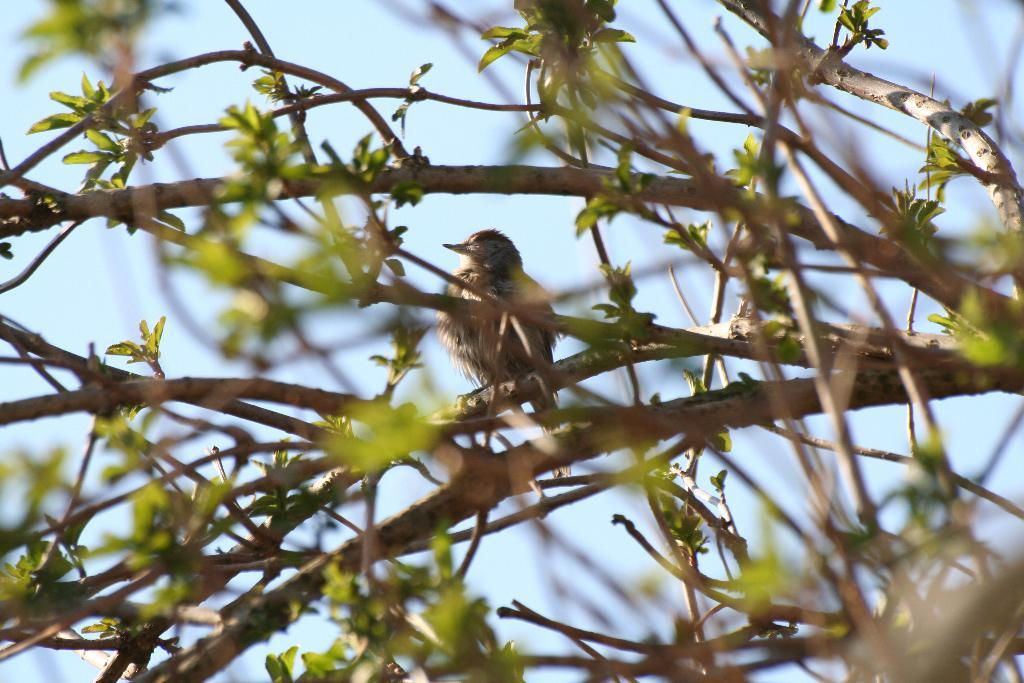What type of animal can be seen in the image? There is a bird in the image. Where is the bird located? The bird is sitting on a green tree. What part of the natural environment is visible in the image? The sky is visible in the image. What type of steam can be seen coming from the bird's beak in the image? There is no steam coming from the bird's beak in the image; the bird is simply sitting on the tree. 